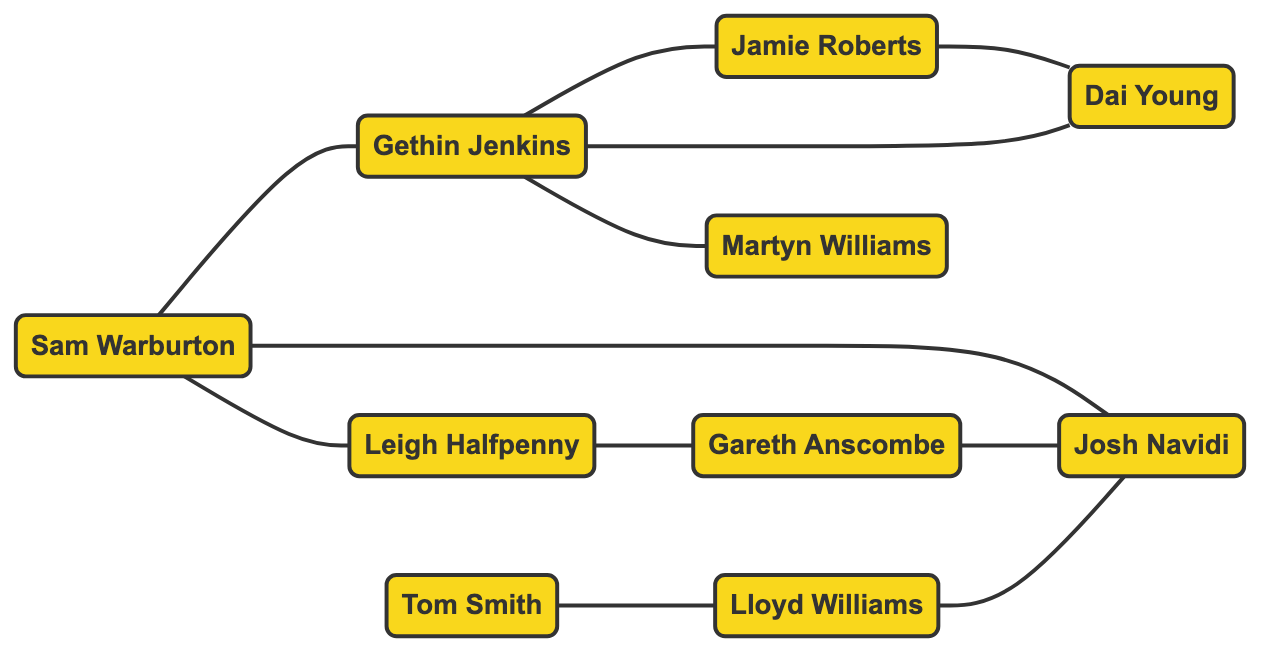What is the total number of players represented in the diagram? The diagram contains 10 nodes, which correspond to 10 different players. By counting each node, we determine the total number of players represented.
Answer: 10 Which player is connected to both Sam Warburton and Gethin Jenkins? By looking at the connections of Sam Warburton, the player who is connected to him and also connected to Gethin Jenkins is Josh Navidi. This requires analyzing the edges connected to both nodes.
Answer: Josh Navidi How many edges are connected to Leigh Halfpenny? In the diagram, there is one edge connected to Leigh Halfpenny, which is the line connecting him to Gareth Anscombe. By only counting the direct connections (edges) linked to this node, we can find the answer.
Answer: 1 Who is connected to the most players? To find the player connected to the most players, we need to look at the degree of each node. Gethin Jenkins has 4 connections: Sam Warburton, Jamie Roberts, Martyn Williams, and Dai Young, which is the highest among all players.
Answer: Gethin Jenkins Is Tom Smith connected to any player? By examining the edges in the diagram, Tom Smith has only one connection to Lloyd Williams. This involves checking the edges to find direct links.
Answer: Yes How many players are connected to Josh Navidi? Josh Navidi is connected to Sam Warburton, Gareth Anscombe, and Lloyd Williams. Counting these connections leads to the answer of how many players are directly linked to him.
Answer: 3 Which two players are connected directly through Dai Young? The players directly connected to Dai Young are Jamie Roberts and Gethin Jenkins. You can find these connections by examining the edges attached to Dai Young's node.
Answer: Jamie Roberts and Gethin Jenkins What is the relationship type represented in this graph? The graph is an undirected graph, indicating that the connections between players do not have a directional flow; they simply represent mutual relationships. This understanding can be derived from how edges are drawn between nodes without any arrows.
Answer: Undirected List the players who are directly connected to Sam Warburton. The players directly connected to Sam Warburton are Gethin Jenkins, Leigh Halfpenny, and Josh Navidi. This requires reviewing the edges that stem from Sam Warburton's node.
Answer: Gethin Jenkins, Leigh Halfpenny, Josh Navidi 